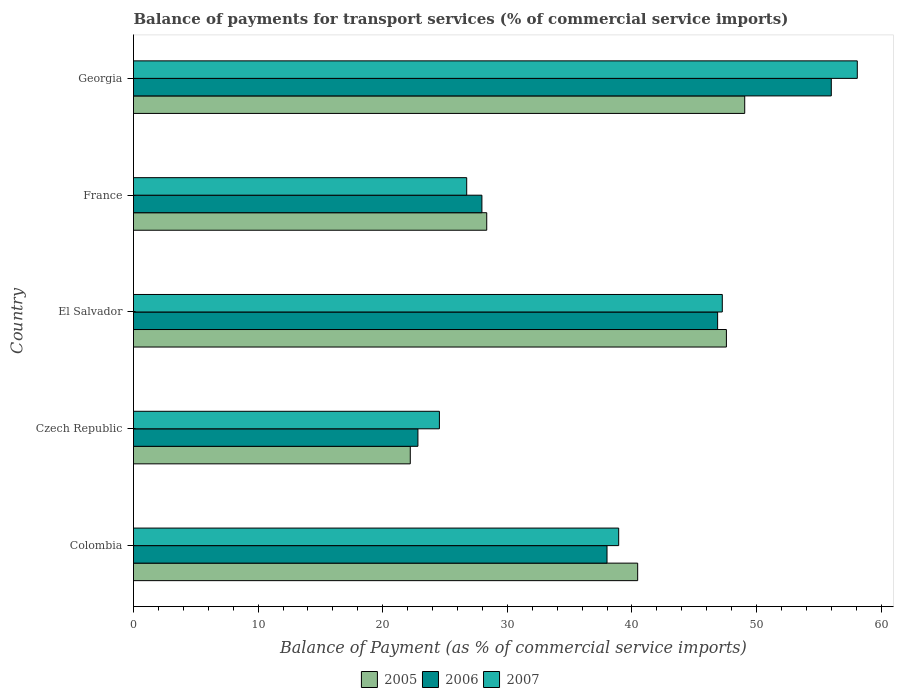How many bars are there on the 2nd tick from the bottom?
Ensure brevity in your answer.  3. What is the label of the 1st group of bars from the top?
Your response must be concise. Georgia. What is the balance of payments for transport services in 2007 in Colombia?
Give a very brief answer. 38.94. Across all countries, what is the maximum balance of payments for transport services in 2006?
Offer a terse response. 56. Across all countries, what is the minimum balance of payments for transport services in 2005?
Provide a succinct answer. 22.21. In which country was the balance of payments for transport services in 2006 maximum?
Your answer should be very brief. Georgia. In which country was the balance of payments for transport services in 2007 minimum?
Ensure brevity in your answer.  Czech Republic. What is the total balance of payments for transport services in 2006 in the graph?
Offer a very short reply. 191.67. What is the difference between the balance of payments for transport services in 2007 in Colombia and that in El Salvador?
Provide a succinct answer. -8.32. What is the difference between the balance of payments for transport services in 2007 in Czech Republic and the balance of payments for transport services in 2006 in Georgia?
Offer a terse response. -31.45. What is the average balance of payments for transport services in 2007 per country?
Provide a succinct answer. 39.11. What is the difference between the balance of payments for transport services in 2006 and balance of payments for transport services in 2007 in Georgia?
Your response must be concise. -2.09. What is the ratio of the balance of payments for transport services in 2005 in Colombia to that in Georgia?
Provide a succinct answer. 0.82. Is the difference between the balance of payments for transport services in 2006 in Colombia and Georgia greater than the difference between the balance of payments for transport services in 2007 in Colombia and Georgia?
Provide a succinct answer. Yes. What is the difference between the highest and the second highest balance of payments for transport services in 2007?
Make the answer very short. 10.83. What is the difference between the highest and the lowest balance of payments for transport services in 2005?
Give a very brief answer. 26.84. In how many countries, is the balance of payments for transport services in 2005 greater than the average balance of payments for transport services in 2005 taken over all countries?
Provide a short and direct response. 3. Is it the case that in every country, the sum of the balance of payments for transport services in 2005 and balance of payments for transport services in 2006 is greater than the balance of payments for transport services in 2007?
Provide a short and direct response. Yes. How many bars are there?
Make the answer very short. 15. What is the difference between two consecutive major ticks on the X-axis?
Provide a succinct answer. 10. Are the values on the major ticks of X-axis written in scientific E-notation?
Provide a short and direct response. No. Where does the legend appear in the graph?
Offer a very short reply. Bottom center. How are the legend labels stacked?
Keep it short and to the point. Horizontal. What is the title of the graph?
Offer a very short reply. Balance of payments for transport services (% of commercial service imports). What is the label or title of the X-axis?
Your response must be concise. Balance of Payment (as % of commercial service imports). What is the label or title of the Y-axis?
Offer a very short reply. Country. What is the Balance of Payment (as % of commercial service imports) of 2005 in Colombia?
Offer a terse response. 40.46. What is the Balance of Payment (as % of commercial service imports) of 2006 in Colombia?
Give a very brief answer. 38. What is the Balance of Payment (as % of commercial service imports) of 2007 in Colombia?
Make the answer very short. 38.94. What is the Balance of Payment (as % of commercial service imports) of 2005 in Czech Republic?
Your answer should be very brief. 22.21. What is the Balance of Payment (as % of commercial service imports) of 2006 in Czech Republic?
Ensure brevity in your answer.  22.82. What is the Balance of Payment (as % of commercial service imports) of 2007 in Czech Republic?
Offer a terse response. 24.55. What is the Balance of Payment (as % of commercial service imports) in 2005 in El Salvador?
Give a very brief answer. 47.58. What is the Balance of Payment (as % of commercial service imports) of 2006 in El Salvador?
Give a very brief answer. 46.88. What is the Balance of Payment (as % of commercial service imports) in 2007 in El Salvador?
Offer a terse response. 47.25. What is the Balance of Payment (as % of commercial service imports) in 2005 in France?
Provide a succinct answer. 28.35. What is the Balance of Payment (as % of commercial service imports) in 2006 in France?
Keep it short and to the point. 27.96. What is the Balance of Payment (as % of commercial service imports) of 2007 in France?
Keep it short and to the point. 26.74. What is the Balance of Payment (as % of commercial service imports) of 2005 in Georgia?
Give a very brief answer. 49.05. What is the Balance of Payment (as % of commercial service imports) of 2006 in Georgia?
Your response must be concise. 56. What is the Balance of Payment (as % of commercial service imports) in 2007 in Georgia?
Offer a terse response. 58.09. Across all countries, what is the maximum Balance of Payment (as % of commercial service imports) of 2005?
Ensure brevity in your answer.  49.05. Across all countries, what is the maximum Balance of Payment (as % of commercial service imports) of 2006?
Offer a terse response. 56. Across all countries, what is the maximum Balance of Payment (as % of commercial service imports) of 2007?
Make the answer very short. 58.09. Across all countries, what is the minimum Balance of Payment (as % of commercial service imports) in 2005?
Offer a terse response. 22.21. Across all countries, what is the minimum Balance of Payment (as % of commercial service imports) of 2006?
Your answer should be compact. 22.82. Across all countries, what is the minimum Balance of Payment (as % of commercial service imports) of 2007?
Offer a very short reply. 24.55. What is the total Balance of Payment (as % of commercial service imports) in 2005 in the graph?
Ensure brevity in your answer.  187.66. What is the total Balance of Payment (as % of commercial service imports) in 2006 in the graph?
Provide a short and direct response. 191.67. What is the total Balance of Payment (as % of commercial service imports) of 2007 in the graph?
Provide a succinct answer. 195.57. What is the difference between the Balance of Payment (as % of commercial service imports) in 2005 in Colombia and that in Czech Republic?
Keep it short and to the point. 18.25. What is the difference between the Balance of Payment (as % of commercial service imports) in 2006 in Colombia and that in Czech Republic?
Provide a succinct answer. 15.18. What is the difference between the Balance of Payment (as % of commercial service imports) in 2007 in Colombia and that in Czech Republic?
Your answer should be very brief. 14.39. What is the difference between the Balance of Payment (as % of commercial service imports) in 2005 in Colombia and that in El Salvador?
Provide a short and direct response. -7.12. What is the difference between the Balance of Payment (as % of commercial service imports) of 2006 in Colombia and that in El Salvador?
Provide a succinct answer. -8.88. What is the difference between the Balance of Payment (as % of commercial service imports) in 2007 in Colombia and that in El Salvador?
Keep it short and to the point. -8.32. What is the difference between the Balance of Payment (as % of commercial service imports) in 2005 in Colombia and that in France?
Ensure brevity in your answer.  12.11. What is the difference between the Balance of Payment (as % of commercial service imports) in 2006 in Colombia and that in France?
Offer a very short reply. 10.04. What is the difference between the Balance of Payment (as % of commercial service imports) in 2007 in Colombia and that in France?
Offer a very short reply. 12.2. What is the difference between the Balance of Payment (as % of commercial service imports) in 2005 in Colombia and that in Georgia?
Keep it short and to the point. -8.59. What is the difference between the Balance of Payment (as % of commercial service imports) in 2007 in Colombia and that in Georgia?
Provide a short and direct response. -19.15. What is the difference between the Balance of Payment (as % of commercial service imports) in 2005 in Czech Republic and that in El Salvador?
Your response must be concise. -25.37. What is the difference between the Balance of Payment (as % of commercial service imports) of 2006 in Czech Republic and that in El Salvador?
Your answer should be very brief. -24.05. What is the difference between the Balance of Payment (as % of commercial service imports) in 2007 in Czech Republic and that in El Salvador?
Make the answer very short. -22.7. What is the difference between the Balance of Payment (as % of commercial service imports) in 2005 in Czech Republic and that in France?
Ensure brevity in your answer.  -6.14. What is the difference between the Balance of Payment (as % of commercial service imports) in 2006 in Czech Republic and that in France?
Give a very brief answer. -5.14. What is the difference between the Balance of Payment (as % of commercial service imports) of 2007 in Czech Republic and that in France?
Offer a terse response. -2.19. What is the difference between the Balance of Payment (as % of commercial service imports) of 2005 in Czech Republic and that in Georgia?
Provide a short and direct response. -26.84. What is the difference between the Balance of Payment (as % of commercial service imports) in 2006 in Czech Republic and that in Georgia?
Ensure brevity in your answer.  -33.18. What is the difference between the Balance of Payment (as % of commercial service imports) in 2007 in Czech Republic and that in Georgia?
Your answer should be compact. -33.54. What is the difference between the Balance of Payment (as % of commercial service imports) in 2005 in El Salvador and that in France?
Offer a very short reply. 19.23. What is the difference between the Balance of Payment (as % of commercial service imports) of 2006 in El Salvador and that in France?
Provide a succinct answer. 18.92. What is the difference between the Balance of Payment (as % of commercial service imports) in 2007 in El Salvador and that in France?
Offer a terse response. 20.51. What is the difference between the Balance of Payment (as % of commercial service imports) in 2005 in El Salvador and that in Georgia?
Your answer should be compact. -1.47. What is the difference between the Balance of Payment (as % of commercial service imports) in 2006 in El Salvador and that in Georgia?
Offer a terse response. -9.12. What is the difference between the Balance of Payment (as % of commercial service imports) of 2007 in El Salvador and that in Georgia?
Offer a terse response. -10.83. What is the difference between the Balance of Payment (as % of commercial service imports) in 2005 in France and that in Georgia?
Give a very brief answer. -20.7. What is the difference between the Balance of Payment (as % of commercial service imports) of 2006 in France and that in Georgia?
Provide a short and direct response. -28.04. What is the difference between the Balance of Payment (as % of commercial service imports) in 2007 in France and that in Georgia?
Provide a succinct answer. -31.35. What is the difference between the Balance of Payment (as % of commercial service imports) of 2005 in Colombia and the Balance of Payment (as % of commercial service imports) of 2006 in Czech Republic?
Give a very brief answer. 17.64. What is the difference between the Balance of Payment (as % of commercial service imports) in 2005 in Colombia and the Balance of Payment (as % of commercial service imports) in 2007 in Czech Republic?
Offer a terse response. 15.91. What is the difference between the Balance of Payment (as % of commercial service imports) in 2006 in Colombia and the Balance of Payment (as % of commercial service imports) in 2007 in Czech Republic?
Give a very brief answer. 13.45. What is the difference between the Balance of Payment (as % of commercial service imports) in 2005 in Colombia and the Balance of Payment (as % of commercial service imports) in 2006 in El Salvador?
Your answer should be very brief. -6.42. What is the difference between the Balance of Payment (as % of commercial service imports) in 2005 in Colombia and the Balance of Payment (as % of commercial service imports) in 2007 in El Salvador?
Your answer should be very brief. -6.79. What is the difference between the Balance of Payment (as % of commercial service imports) of 2006 in Colombia and the Balance of Payment (as % of commercial service imports) of 2007 in El Salvador?
Offer a terse response. -9.25. What is the difference between the Balance of Payment (as % of commercial service imports) in 2005 in Colombia and the Balance of Payment (as % of commercial service imports) in 2006 in France?
Offer a terse response. 12.5. What is the difference between the Balance of Payment (as % of commercial service imports) of 2005 in Colombia and the Balance of Payment (as % of commercial service imports) of 2007 in France?
Your answer should be very brief. 13.72. What is the difference between the Balance of Payment (as % of commercial service imports) in 2006 in Colombia and the Balance of Payment (as % of commercial service imports) in 2007 in France?
Your response must be concise. 11.26. What is the difference between the Balance of Payment (as % of commercial service imports) of 2005 in Colombia and the Balance of Payment (as % of commercial service imports) of 2006 in Georgia?
Keep it short and to the point. -15.54. What is the difference between the Balance of Payment (as % of commercial service imports) in 2005 in Colombia and the Balance of Payment (as % of commercial service imports) in 2007 in Georgia?
Make the answer very short. -17.63. What is the difference between the Balance of Payment (as % of commercial service imports) of 2006 in Colombia and the Balance of Payment (as % of commercial service imports) of 2007 in Georgia?
Offer a very short reply. -20.09. What is the difference between the Balance of Payment (as % of commercial service imports) of 2005 in Czech Republic and the Balance of Payment (as % of commercial service imports) of 2006 in El Salvador?
Your answer should be compact. -24.67. What is the difference between the Balance of Payment (as % of commercial service imports) in 2005 in Czech Republic and the Balance of Payment (as % of commercial service imports) in 2007 in El Salvador?
Provide a short and direct response. -25.04. What is the difference between the Balance of Payment (as % of commercial service imports) of 2006 in Czech Republic and the Balance of Payment (as % of commercial service imports) of 2007 in El Salvador?
Offer a terse response. -24.43. What is the difference between the Balance of Payment (as % of commercial service imports) in 2005 in Czech Republic and the Balance of Payment (as % of commercial service imports) in 2006 in France?
Offer a very short reply. -5.75. What is the difference between the Balance of Payment (as % of commercial service imports) in 2005 in Czech Republic and the Balance of Payment (as % of commercial service imports) in 2007 in France?
Your response must be concise. -4.53. What is the difference between the Balance of Payment (as % of commercial service imports) of 2006 in Czech Republic and the Balance of Payment (as % of commercial service imports) of 2007 in France?
Ensure brevity in your answer.  -3.92. What is the difference between the Balance of Payment (as % of commercial service imports) of 2005 in Czech Republic and the Balance of Payment (as % of commercial service imports) of 2006 in Georgia?
Offer a terse response. -33.79. What is the difference between the Balance of Payment (as % of commercial service imports) in 2005 in Czech Republic and the Balance of Payment (as % of commercial service imports) in 2007 in Georgia?
Make the answer very short. -35.88. What is the difference between the Balance of Payment (as % of commercial service imports) in 2006 in Czech Republic and the Balance of Payment (as % of commercial service imports) in 2007 in Georgia?
Offer a very short reply. -35.26. What is the difference between the Balance of Payment (as % of commercial service imports) of 2005 in El Salvador and the Balance of Payment (as % of commercial service imports) of 2006 in France?
Offer a very short reply. 19.62. What is the difference between the Balance of Payment (as % of commercial service imports) of 2005 in El Salvador and the Balance of Payment (as % of commercial service imports) of 2007 in France?
Your answer should be very brief. 20.84. What is the difference between the Balance of Payment (as % of commercial service imports) of 2006 in El Salvador and the Balance of Payment (as % of commercial service imports) of 2007 in France?
Make the answer very short. 20.14. What is the difference between the Balance of Payment (as % of commercial service imports) of 2005 in El Salvador and the Balance of Payment (as % of commercial service imports) of 2006 in Georgia?
Offer a very short reply. -8.42. What is the difference between the Balance of Payment (as % of commercial service imports) in 2005 in El Salvador and the Balance of Payment (as % of commercial service imports) in 2007 in Georgia?
Ensure brevity in your answer.  -10.51. What is the difference between the Balance of Payment (as % of commercial service imports) in 2006 in El Salvador and the Balance of Payment (as % of commercial service imports) in 2007 in Georgia?
Provide a short and direct response. -11.21. What is the difference between the Balance of Payment (as % of commercial service imports) in 2005 in France and the Balance of Payment (as % of commercial service imports) in 2006 in Georgia?
Offer a terse response. -27.65. What is the difference between the Balance of Payment (as % of commercial service imports) in 2005 in France and the Balance of Payment (as % of commercial service imports) in 2007 in Georgia?
Your answer should be compact. -29.74. What is the difference between the Balance of Payment (as % of commercial service imports) of 2006 in France and the Balance of Payment (as % of commercial service imports) of 2007 in Georgia?
Provide a short and direct response. -30.13. What is the average Balance of Payment (as % of commercial service imports) of 2005 per country?
Your answer should be compact. 37.53. What is the average Balance of Payment (as % of commercial service imports) of 2006 per country?
Make the answer very short. 38.33. What is the average Balance of Payment (as % of commercial service imports) of 2007 per country?
Ensure brevity in your answer.  39.11. What is the difference between the Balance of Payment (as % of commercial service imports) in 2005 and Balance of Payment (as % of commercial service imports) in 2006 in Colombia?
Offer a very short reply. 2.46. What is the difference between the Balance of Payment (as % of commercial service imports) in 2005 and Balance of Payment (as % of commercial service imports) in 2007 in Colombia?
Provide a succinct answer. 1.52. What is the difference between the Balance of Payment (as % of commercial service imports) in 2006 and Balance of Payment (as % of commercial service imports) in 2007 in Colombia?
Keep it short and to the point. -0.94. What is the difference between the Balance of Payment (as % of commercial service imports) in 2005 and Balance of Payment (as % of commercial service imports) in 2006 in Czech Republic?
Provide a succinct answer. -0.61. What is the difference between the Balance of Payment (as % of commercial service imports) in 2005 and Balance of Payment (as % of commercial service imports) in 2007 in Czech Republic?
Provide a short and direct response. -2.34. What is the difference between the Balance of Payment (as % of commercial service imports) in 2006 and Balance of Payment (as % of commercial service imports) in 2007 in Czech Republic?
Your answer should be very brief. -1.72. What is the difference between the Balance of Payment (as % of commercial service imports) of 2005 and Balance of Payment (as % of commercial service imports) of 2006 in El Salvador?
Your answer should be very brief. 0.7. What is the difference between the Balance of Payment (as % of commercial service imports) in 2005 and Balance of Payment (as % of commercial service imports) in 2007 in El Salvador?
Provide a succinct answer. 0.33. What is the difference between the Balance of Payment (as % of commercial service imports) in 2006 and Balance of Payment (as % of commercial service imports) in 2007 in El Salvador?
Keep it short and to the point. -0.38. What is the difference between the Balance of Payment (as % of commercial service imports) of 2005 and Balance of Payment (as % of commercial service imports) of 2006 in France?
Offer a terse response. 0.39. What is the difference between the Balance of Payment (as % of commercial service imports) in 2005 and Balance of Payment (as % of commercial service imports) in 2007 in France?
Provide a succinct answer. 1.61. What is the difference between the Balance of Payment (as % of commercial service imports) of 2006 and Balance of Payment (as % of commercial service imports) of 2007 in France?
Keep it short and to the point. 1.22. What is the difference between the Balance of Payment (as % of commercial service imports) of 2005 and Balance of Payment (as % of commercial service imports) of 2006 in Georgia?
Your response must be concise. -6.95. What is the difference between the Balance of Payment (as % of commercial service imports) of 2005 and Balance of Payment (as % of commercial service imports) of 2007 in Georgia?
Offer a terse response. -9.04. What is the difference between the Balance of Payment (as % of commercial service imports) of 2006 and Balance of Payment (as % of commercial service imports) of 2007 in Georgia?
Provide a succinct answer. -2.09. What is the ratio of the Balance of Payment (as % of commercial service imports) of 2005 in Colombia to that in Czech Republic?
Offer a terse response. 1.82. What is the ratio of the Balance of Payment (as % of commercial service imports) of 2006 in Colombia to that in Czech Republic?
Provide a short and direct response. 1.66. What is the ratio of the Balance of Payment (as % of commercial service imports) of 2007 in Colombia to that in Czech Republic?
Give a very brief answer. 1.59. What is the ratio of the Balance of Payment (as % of commercial service imports) in 2005 in Colombia to that in El Salvador?
Make the answer very short. 0.85. What is the ratio of the Balance of Payment (as % of commercial service imports) in 2006 in Colombia to that in El Salvador?
Your response must be concise. 0.81. What is the ratio of the Balance of Payment (as % of commercial service imports) in 2007 in Colombia to that in El Salvador?
Provide a short and direct response. 0.82. What is the ratio of the Balance of Payment (as % of commercial service imports) of 2005 in Colombia to that in France?
Your response must be concise. 1.43. What is the ratio of the Balance of Payment (as % of commercial service imports) in 2006 in Colombia to that in France?
Your answer should be compact. 1.36. What is the ratio of the Balance of Payment (as % of commercial service imports) of 2007 in Colombia to that in France?
Provide a succinct answer. 1.46. What is the ratio of the Balance of Payment (as % of commercial service imports) in 2005 in Colombia to that in Georgia?
Ensure brevity in your answer.  0.82. What is the ratio of the Balance of Payment (as % of commercial service imports) in 2006 in Colombia to that in Georgia?
Your answer should be compact. 0.68. What is the ratio of the Balance of Payment (as % of commercial service imports) of 2007 in Colombia to that in Georgia?
Offer a terse response. 0.67. What is the ratio of the Balance of Payment (as % of commercial service imports) in 2005 in Czech Republic to that in El Salvador?
Ensure brevity in your answer.  0.47. What is the ratio of the Balance of Payment (as % of commercial service imports) in 2006 in Czech Republic to that in El Salvador?
Your answer should be very brief. 0.49. What is the ratio of the Balance of Payment (as % of commercial service imports) in 2007 in Czech Republic to that in El Salvador?
Make the answer very short. 0.52. What is the ratio of the Balance of Payment (as % of commercial service imports) of 2005 in Czech Republic to that in France?
Give a very brief answer. 0.78. What is the ratio of the Balance of Payment (as % of commercial service imports) in 2006 in Czech Republic to that in France?
Your answer should be compact. 0.82. What is the ratio of the Balance of Payment (as % of commercial service imports) in 2007 in Czech Republic to that in France?
Make the answer very short. 0.92. What is the ratio of the Balance of Payment (as % of commercial service imports) in 2005 in Czech Republic to that in Georgia?
Offer a terse response. 0.45. What is the ratio of the Balance of Payment (as % of commercial service imports) in 2006 in Czech Republic to that in Georgia?
Ensure brevity in your answer.  0.41. What is the ratio of the Balance of Payment (as % of commercial service imports) of 2007 in Czech Republic to that in Georgia?
Offer a very short reply. 0.42. What is the ratio of the Balance of Payment (as % of commercial service imports) in 2005 in El Salvador to that in France?
Offer a very short reply. 1.68. What is the ratio of the Balance of Payment (as % of commercial service imports) of 2006 in El Salvador to that in France?
Your answer should be very brief. 1.68. What is the ratio of the Balance of Payment (as % of commercial service imports) in 2007 in El Salvador to that in France?
Provide a short and direct response. 1.77. What is the ratio of the Balance of Payment (as % of commercial service imports) of 2005 in El Salvador to that in Georgia?
Ensure brevity in your answer.  0.97. What is the ratio of the Balance of Payment (as % of commercial service imports) of 2006 in El Salvador to that in Georgia?
Your answer should be compact. 0.84. What is the ratio of the Balance of Payment (as % of commercial service imports) in 2007 in El Salvador to that in Georgia?
Ensure brevity in your answer.  0.81. What is the ratio of the Balance of Payment (as % of commercial service imports) of 2005 in France to that in Georgia?
Provide a short and direct response. 0.58. What is the ratio of the Balance of Payment (as % of commercial service imports) of 2006 in France to that in Georgia?
Provide a succinct answer. 0.5. What is the ratio of the Balance of Payment (as % of commercial service imports) of 2007 in France to that in Georgia?
Ensure brevity in your answer.  0.46. What is the difference between the highest and the second highest Balance of Payment (as % of commercial service imports) in 2005?
Make the answer very short. 1.47. What is the difference between the highest and the second highest Balance of Payment (as % of commercial service imports) of 2006?
Provide a short and direct response. 9.12. What is the difference between the highest and the second highest Balance of Payment (as % of commercial service imports) in 2007?
Your answer should be compact. 10.83. What is the difference between the highest and the lowest Balance of Payment (as % of commercial service imports) in 2005?
Your answer should be compact. 26.84. What is the difference between the highest and the lowest Balance of Payment (as % of commercial service imports) of 2006?
Offer a terse response. 33.18. What is the difference between the highest and the lowest Balance of Payment (as % of commercial service imports) of 2007?
Your response must be concise. 33.54. 